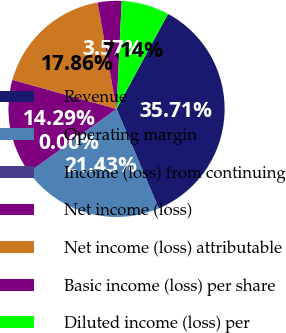Convert chart to OTSL. <chart><loc_0><loc_0><loc_500><loc_500><pie_chart><fcel>Revenue<fcel>Operating margin<fcel>Income (loss) from continuing<fcel>Net income (loss)<fcel>Net income (loss) attributable<fcel>Basic income (loss) per share<fcel>Diluted income (loss) per<nl><fcel>35.71%<fcel>21.43%<fcel>0.0%<fcel>14.29%<fcel>17.86%<fcel>3.57%<fcel>7.14%<nl></chart> 